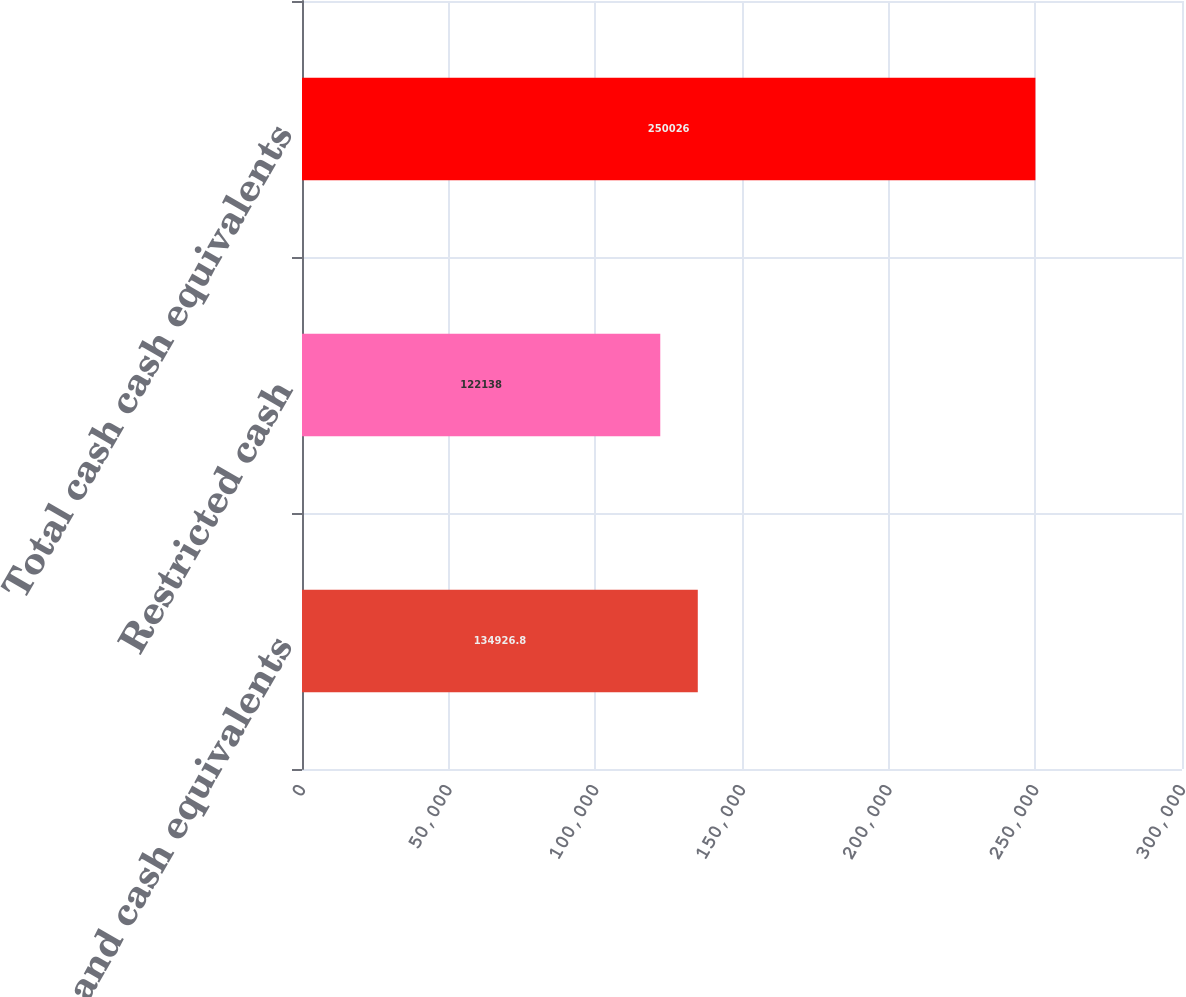Convert chart. <chart><loc_0><loc_0><loc_500><loc_500><bar_chart><fcel>Cash and cash equivalents<fcel>Restricted cash<fcel>Total cash cash equivalents<nl><fcel>134927<fcel>122138<fcel>250026<nl></chart> 